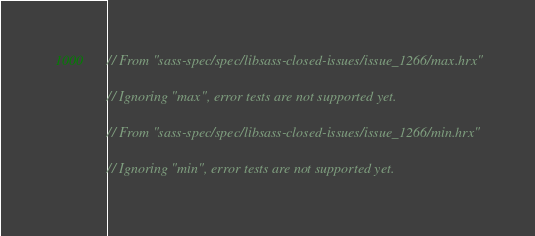Convert code to text. <code><loc_0><loc_0><loc_500><loc_500><_Rust_>
// From "sass-spec/spec/libsass-closed-issues/issue_1266/max.hrx"

// Ignoring "max", error tests are not supported yet.

// From "sass-spec/spec/libsass-closed-issues/issue_1266/min.hrx"

// Ignoring "min", error tests are not supported yet.
</code> 